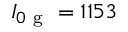<formula> <loc_0><loc_0><loc_500><loc_500>I _ { 0 g } = 1 1 5 3</formula> 